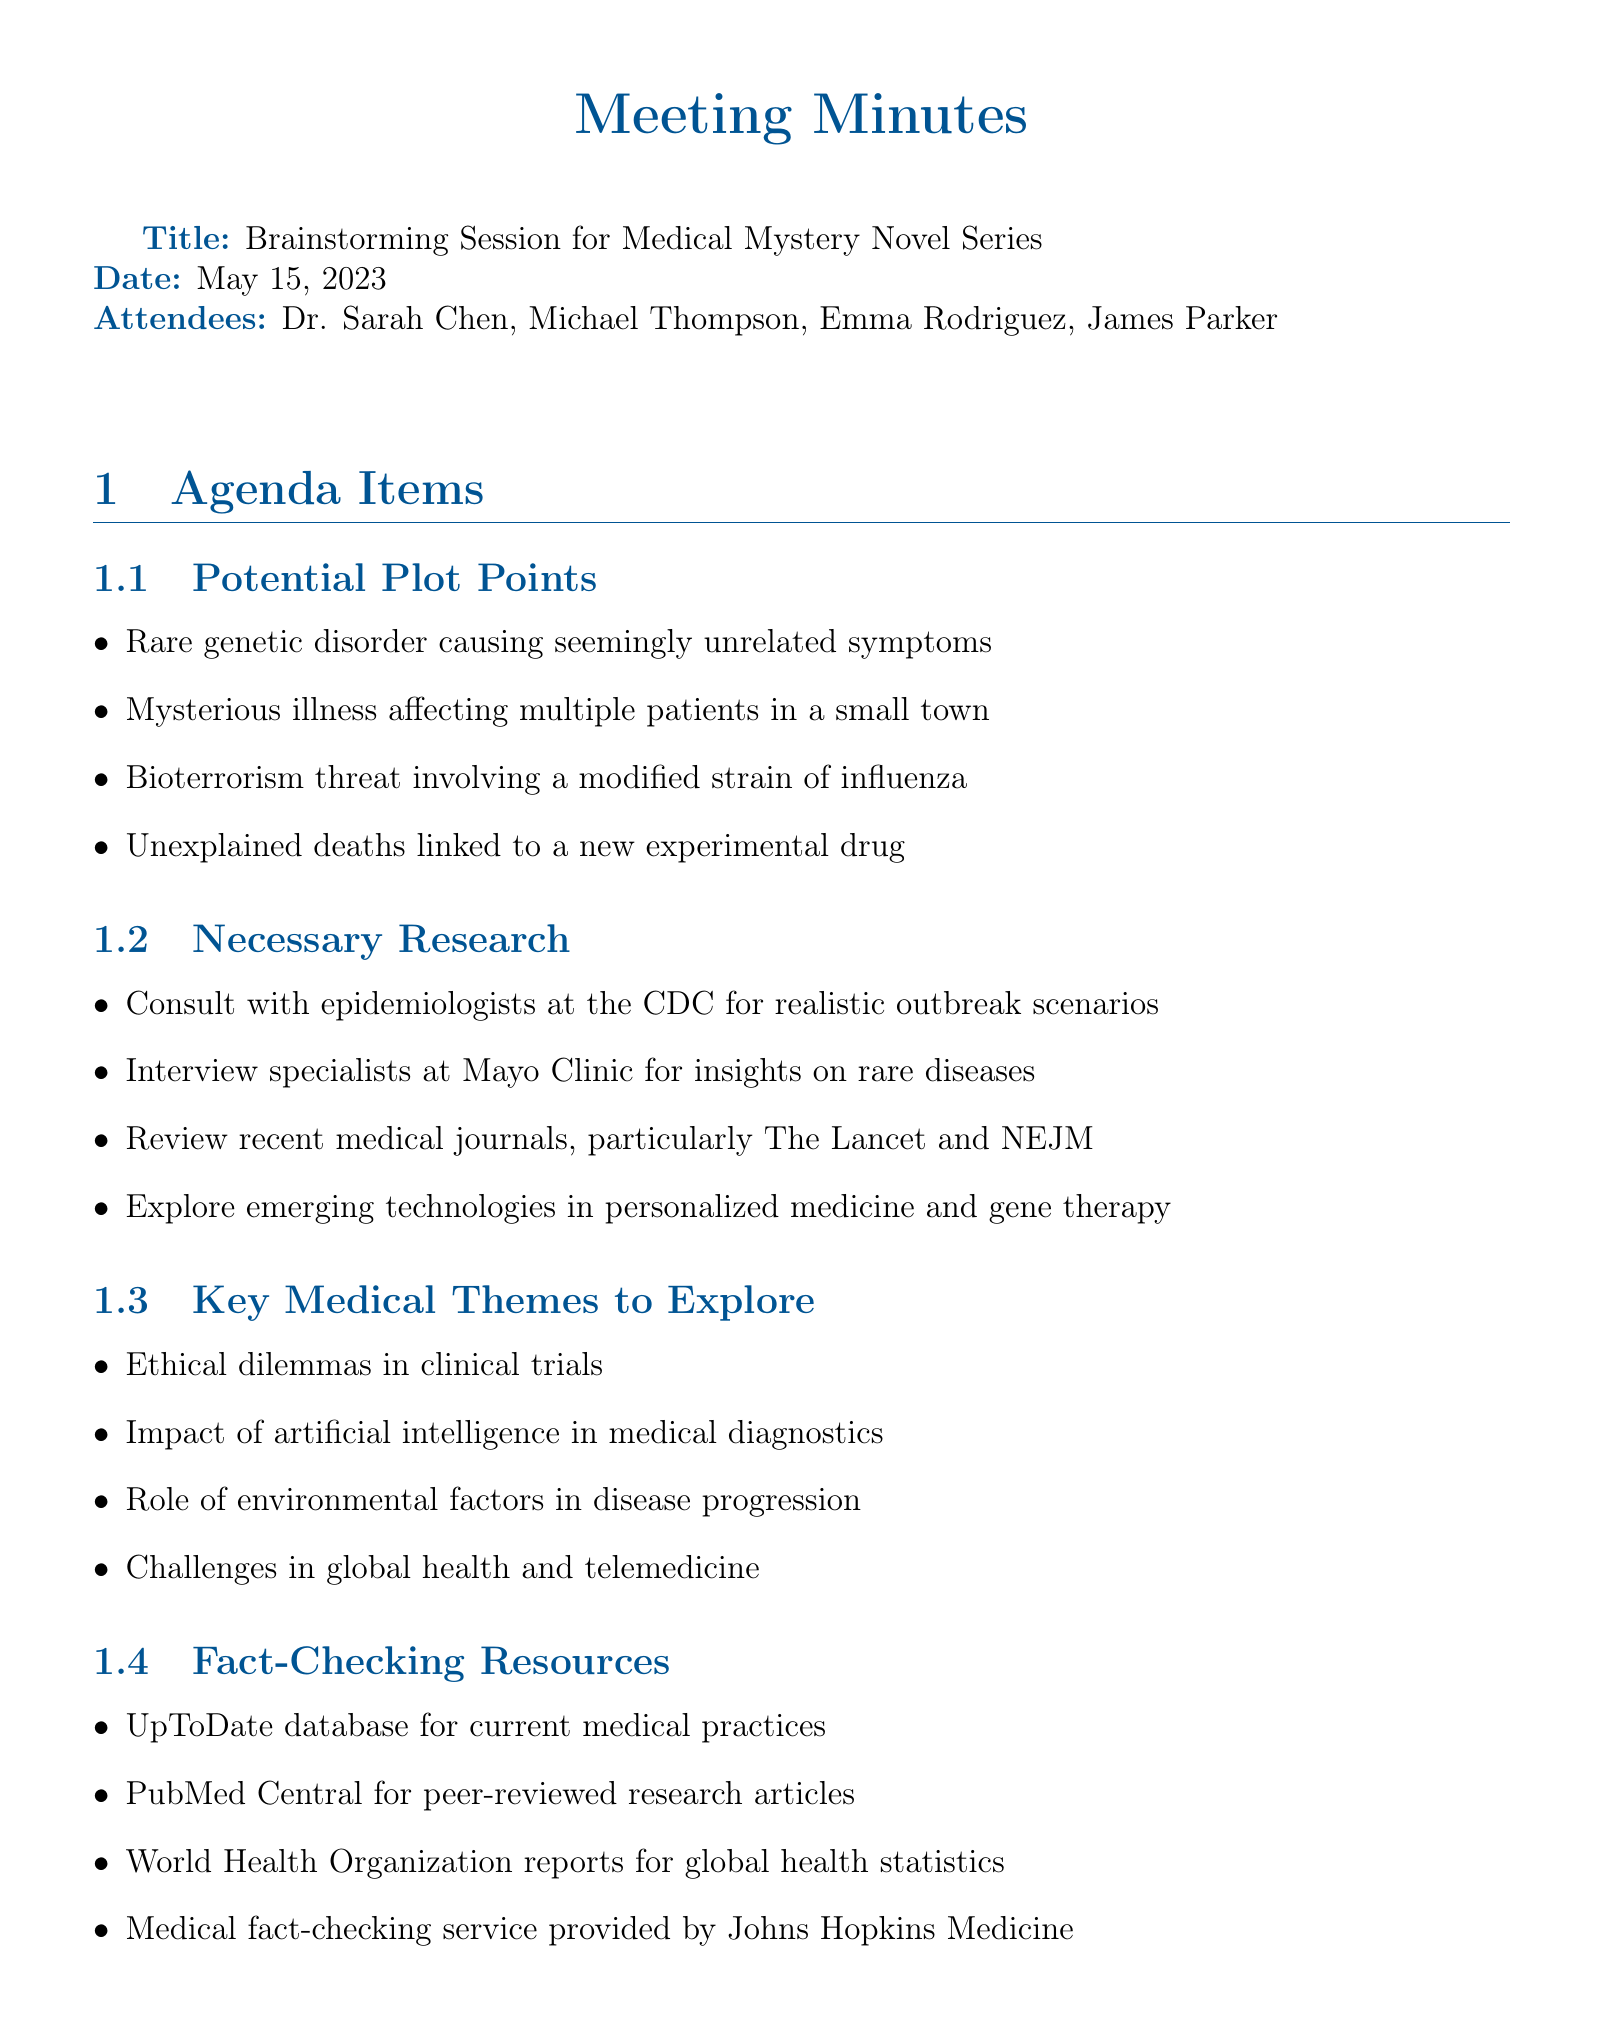what is the meeting title? The meeting title is provided at the beginning of the document.
Answer: Brainstorming Session for Medical Mystery Novel Series who are the attendees? The attendees are listed in the section dedicated to attendees.
Answer: Dr. Sarah Chen, Michael Thompson, Emma Rodriguez, James Parker what is the date of the next meeting? The date for the next meeting is explicitly mentioned in the document.
Answer: May 29, 2023 which key medical theme involves AI? This theme is explicitly mentioned under key medical themes to explore in the document.
Answer: Impact of artificial intelligence in medical diagnostics how many potential plot points are listed? The document specifies the number of plot points in the agenda item.
Answer: four what are the fact-checking resources mentioned? This question asks for a specific type of information regarding resources listed in the document.
Answer: UpToDate database for current medical practices, PubMed Central for peer-reviewed research articles, World Health Organization reports for global health statistics, Medical fact-checking service provided by Johns Hopkins Medicine who is responsible for compiling a list of medical experts? The action items section specifies who is assigned this task.
Answer: Emma what is one action item assigned to James? The tasks assigned to each member are listed as action items in the document.
Answer: draft initial plot outlines for review by next meeting 